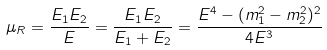Convert formula to latex. <formula><loc_0><loc_0><loc_500><loc_500>\mu _ { R } = \frac { E _ { 1 } E _ { 2 } } { E } = \frac { E _ { 1 } E _ { 2 } } { E _ { 1 } + E _ { 2 } } = \frac { E ^ { 4 } - ( m ^ { 2 } _ { 1 } - m ^ { 2 } _ { 2 } ) ^ { 2 } } { 4 E ^ { 3 } }</formula> 